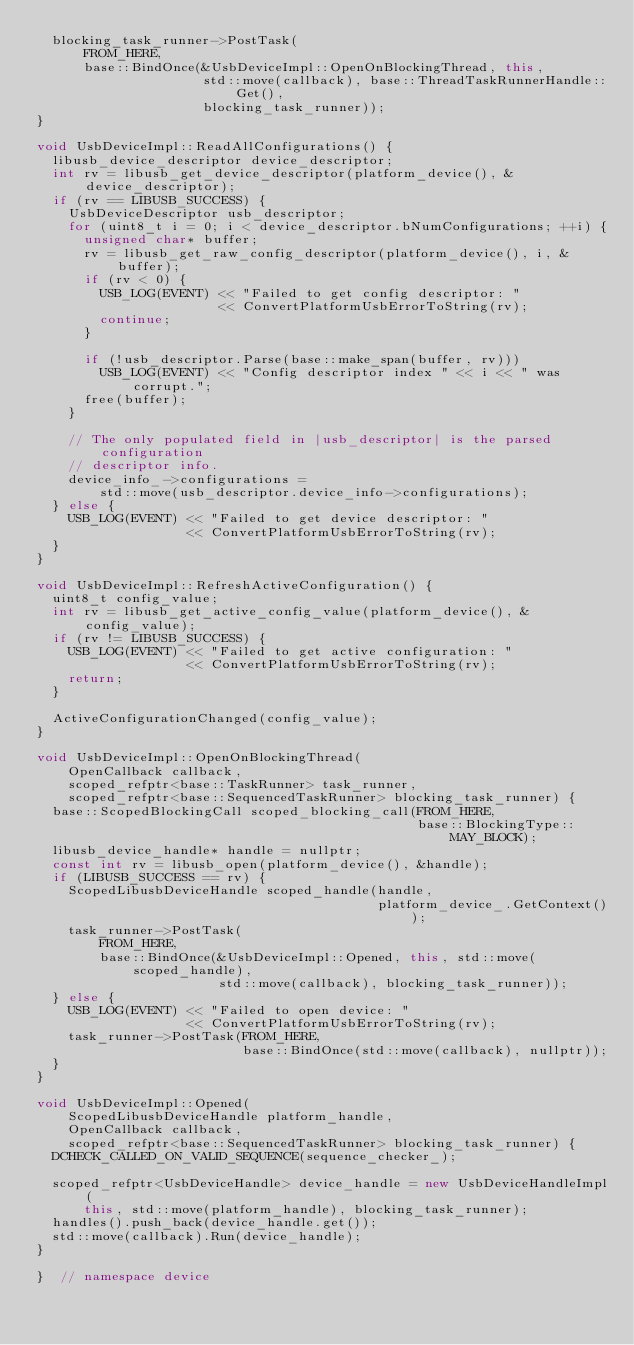Convert code to text. <code><loc_0><loc_0><loc_500><loc_500><_C++_>  blocking_task_runner->PostTask(
      FROM_HERE,
      base::BindOnce(&UsbDeviceImpl::OpenOnBlockingThread, this,
                     std::move(callback), base::ThreadTaskRunnerHandle::Get(),
                     blocking_task_runner));
}

void UsbDeviceImpl::ReadAllConfigurations() {
  libusb_device_descriptor device_descriptor;
  int rv = libusb_get_device_descriptor(platform_device(), &device_descriptor);
  if (rv == LIBUSB_SUCCESS) {
    UsbDeviceDescriptor usb_descriptor;
    for (uint8_t i = 0; i < device_descriptor.bNumConfigurations; ++i) {
      unsigned char* buffer;
      rv = libusb_get_raw_config_descriptor(platform_device(), i, &buffer);
      if (rv < 0) {
        USB_LOG(EVENT) << "Failed to get config descriptor: "
                       << ConvertPlatformUsbErrorToString(rv);
        continue;
      }

      if (!usb_descriptor.Parse(base::make_span(buffer, rv)))
        USB_LOG(EVENT) << "Config descriptor index " << i << " was corrupt.";
      free(buffer);
    }

    // The only populated field in |usb_descriptor| is the parsed configuration
    // descriptor info.
    device_info_->configurations =
        std::move(usb_descriptor.device_info->configurations);
  } else {
    USB_LOG(EVENT) << "Failed to get device descriptor: "
                   << ConvertPlatformUsbErrorToString(rv);
  }
}

void UsbDeviceImpl::RefreshActiveConfiguration() {
  uint8_t config_value;
  int rv = libusb_get_active_config_value(platform_device(), &config_value);
  if (rv != LIBUSB_SUCCESS) {
    USB_LOG(EVENT) << "Failed to get active configuration: "
                   << ConvertPlatformUsbErrorToString(rv);
    return;
  }

  ActiveConfigurationChanged(config_value);
}

void UsbDeviceImpl::OpenOnBlockingThread(
    OpenCallback callback,
    scoped_refptr<base::TaskRunner> task_runner,
    scoped_refptr<base::SequencedTaskRunner> blocking_task_runner) {
  base::ScopedBlockingCall scoped_blocking_call(FROM_HERE,
                                                base::BlockingType::MAY_BLOCK);
  libusb_device_handle* handle = nullptr;
  const int rv = libusb_open(platform_device(), &handle);
  if (LIBUSB_SUCCESS == rv) {
    ScopedLibusbDeviceHandle scoped_handle(handle,
                                           platform_device_.GetContext());
    task_runner->PostTask(
        FROM_HERE,
        base::BindOnce(&UsbDeviceImpl::Opened, this, std::move(scoped_handle),
                       std::move(callback), blocking_task_runner));
  } else {
    USB_LOG(EVENT) << "Failed to open device: "
                   << ConvertPlatformUsbErrorToString(rv);
    task_runner->PostTask(FROM_HERE,
                          base::BindOnce(std::move(callback), nullptr));
  }
}

void UsbDeviceImpl::Opened(
    ScopedLibusbDeviceHandle platform_handle,
    OpenCallback callback,
    scoped_refptr<base::SequencedTaskRunner> blocking_task_runner) {
  DCHECK_CALLED_ON_VALID_SEQUENCE(sequence_checker_);

  scoped_refptr<UsbDeviceHandle> device_handle = new UsbDeviceHandleImpl(
      this, std::move(platform_handle), blocking_task_runner);
  handles().push_back(device_handle.get());
  std::move(callback).Run(device_handle);
}

}  // namespace device
</code> 